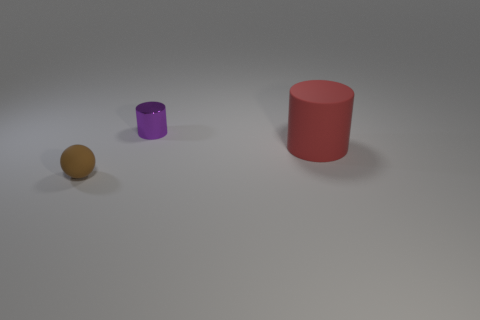Is there any other thing that is made of the same material as the purple object?
Provide a succinct answer. No. How many red cylinders have the same size as the shiny object?
Offer a very short reply. 0. There is a rubber thing in front of the rubber cylinder; is there a purple cylinder behind it?
Your response must be concise. Yes. What number of objects are red matte cylinders or purple metallic cylinders?
Your response must be concise. 2. The small object behind the matte thing left of the matte thing on the right side of the tiny ball is what color?
Ensure brevity in your answer.  Purple. Is there anything else of the same color as the large rubber cylinder?
Your answer should be very brief. No. Is the brown rubber object the same size as the metallic cylinder?
Offer a very short reply. Yes. How many things are matte things that are to the left of the shiny object or things to the left of the small purple metallic object?
Provide a short and direct response. 1. What is the material of the small object that is right of the small thing in front of the large red matte cylinder?
Provide a short and direct response. Metal. What number of other objects are the same material as the small cylinder?
Your response must be concise. 0. 